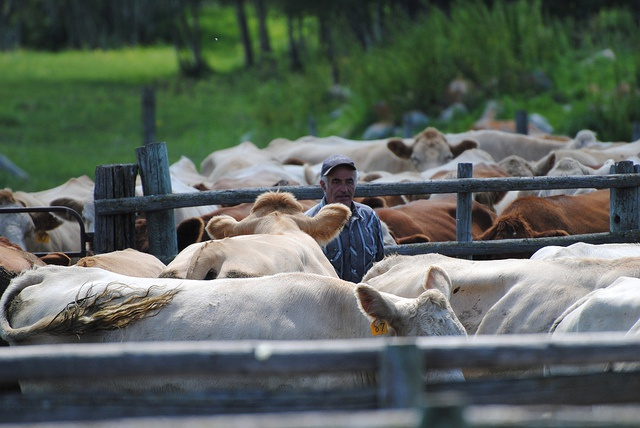Describe the objects in this image and their specific colors. I can see cow in black, darkgray, lightgray, and gray tones, cow in black, lightgray, darkgray, and gray tones, cow in black, lightgray, darkgray, tan, and gray tones, cow in black, lightgray, gray, and darkgray tones, and cow in black, darkgray, and gray tones in this image. 